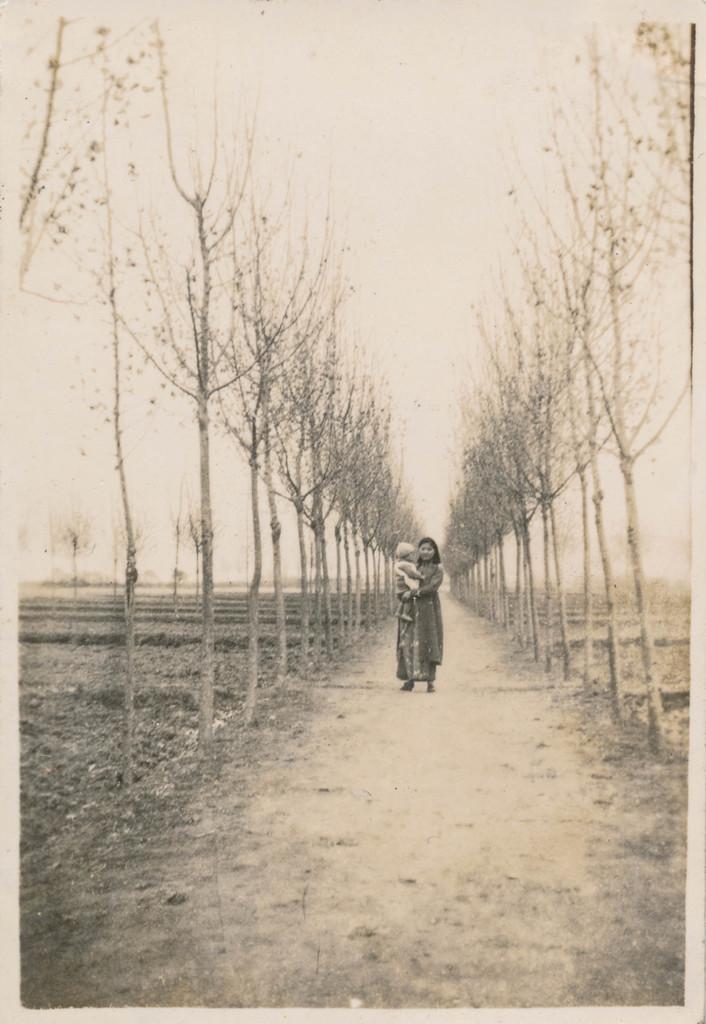Could you give a brief overview of what you see in this image? In this picture we can see the a woman standing on the path and she is carrying a child and in the background we can see trees and the sky. 